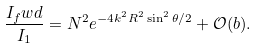Convert formula to latex. <formula><loc_0><loc_0><loc_500><loc_500>\frac { I _ { f } w d } { I _ { 1 } } = N ^ { 2 } e ^ { - 4 k ^ { 2 } R ^ { 2 } \sin ^ { 2 } \theta / 2 } + \mathcal { O } ( b ) .</formula> 